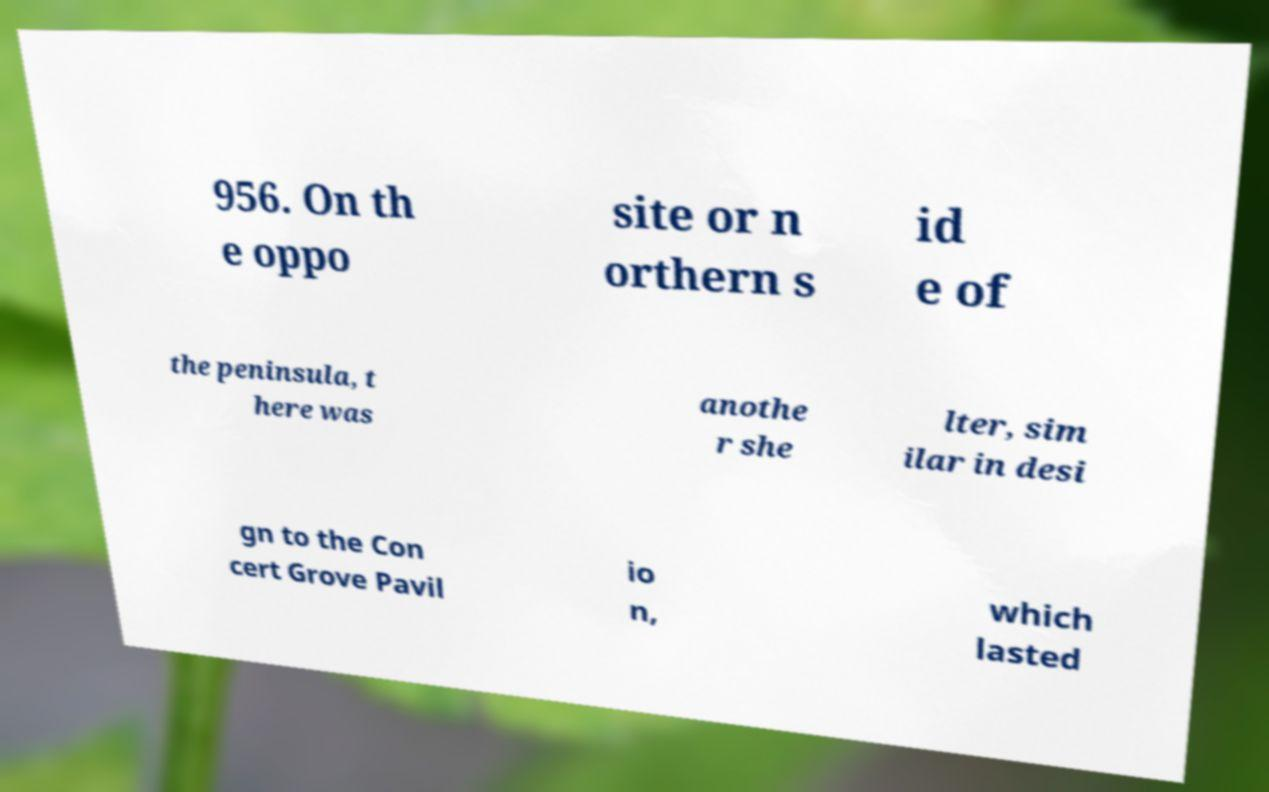Could you assist in decoding the text presented in this image and type it out clearly? 956. On th e oppo site or n orthern s id e of the peninsula, t here was anothe r she lter, sim ilar in desi gn to the Con cert Grove Pavil io n, which lasted 